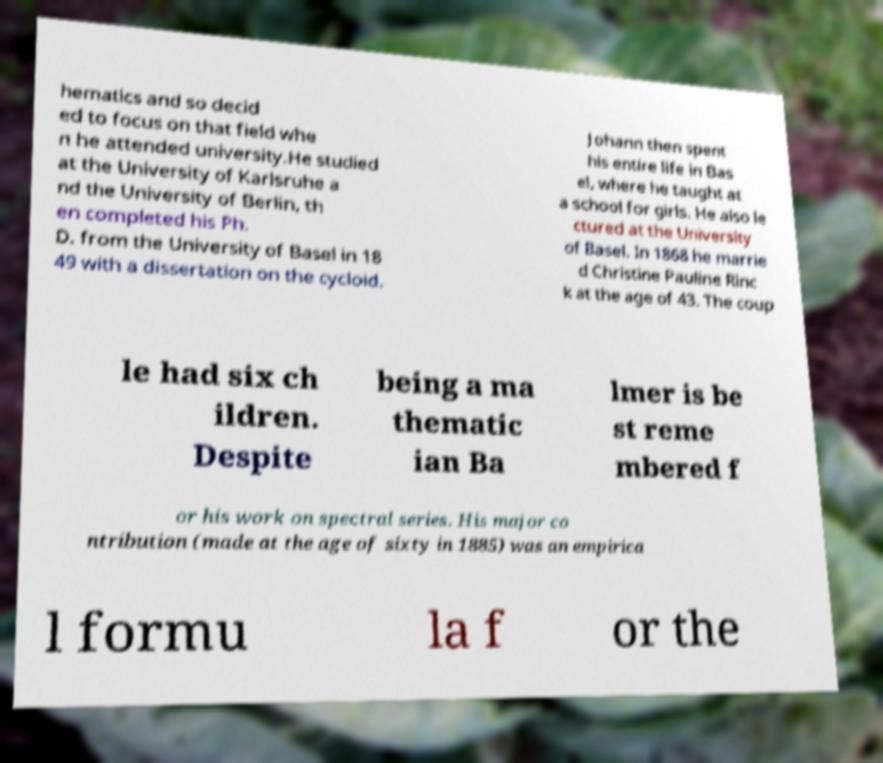Please read and relay the text visible in this image. What does it say? hematics and so decid ed to focus on that field whe n he attended university.He studied at the University of Karlsruhe a nd the University of Berlin, th en completed his Ph. D. from the University of Basel in 18 49 with a dissertation on the cycloid. Johann then spent his entire life in Bas el, where he taught at a school for girls. He also le ctured at the University of Basel. In 1868 he marrie d Christine Pauline Rinc k at the age of 43. The coup le had six ch ildren. Despite being a ma thematic ian Ba lmer is be st reme mbered f or his work on spectral series. His major co ntribution (made at the age of sixty in 1885) was an empirica l formu la f or the 